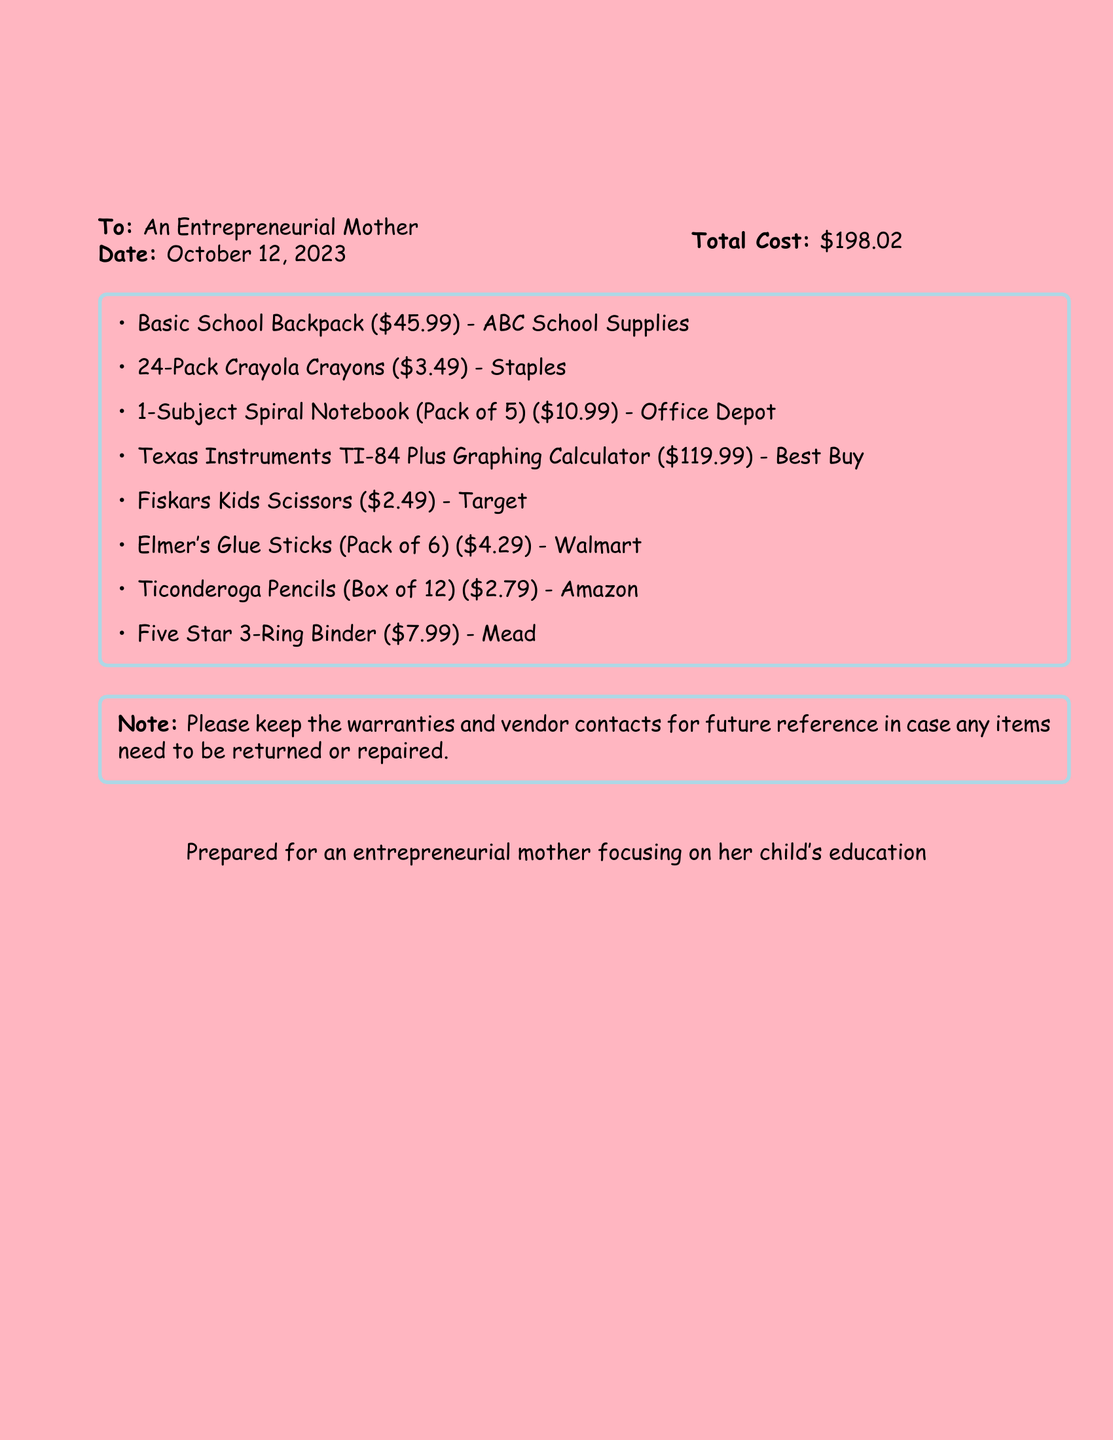what is the total cost? The total cost is explicitly stated in the document and represents the total amount spent on school supplies, which is $198.02.
Answer: $198.02 who is the receipt addressed to? The document specifies the recipient of the receipt, which is an entrepreneurial mother.
Answer: An Entrepreneurial Mother what is the date on the receipt? The date is clearly mentioned in the document, indicating when the receipt was issued, which is October 12, 2023.
Answer: October 12, 2023 which item has the highest cost? The item list includes various school supplies, and the one with the highest cost is the Texas Instruments TI-84 Plus Graphing Calculator, which is $119.99.
Answer: Texas Instruments TI-84 Plus Graphing Calculator how many crayons are in the pack? The receipt details the quantity of crayons included in the pack, which is a 24-pack of Crayola Crayons.
Answer: 24-Pack what is the vendor for the Basic School Backpack? Each item on the list specifies a vendor, and the vendor for the Basic School Backpack is ABC School Supplies.
Answer: ABC School Supplies what item is labeled as a note in the document? The note at the bottom of the document reminders the recipient to keep warranties and vendor contacts.
Answer: Note what is the warranty information concerning items? The document advises keeping warranties and vendor contacts for future reference regarding returns or repairs, highlighting its importance.
Answer: Keep warranties and vendor contacts 